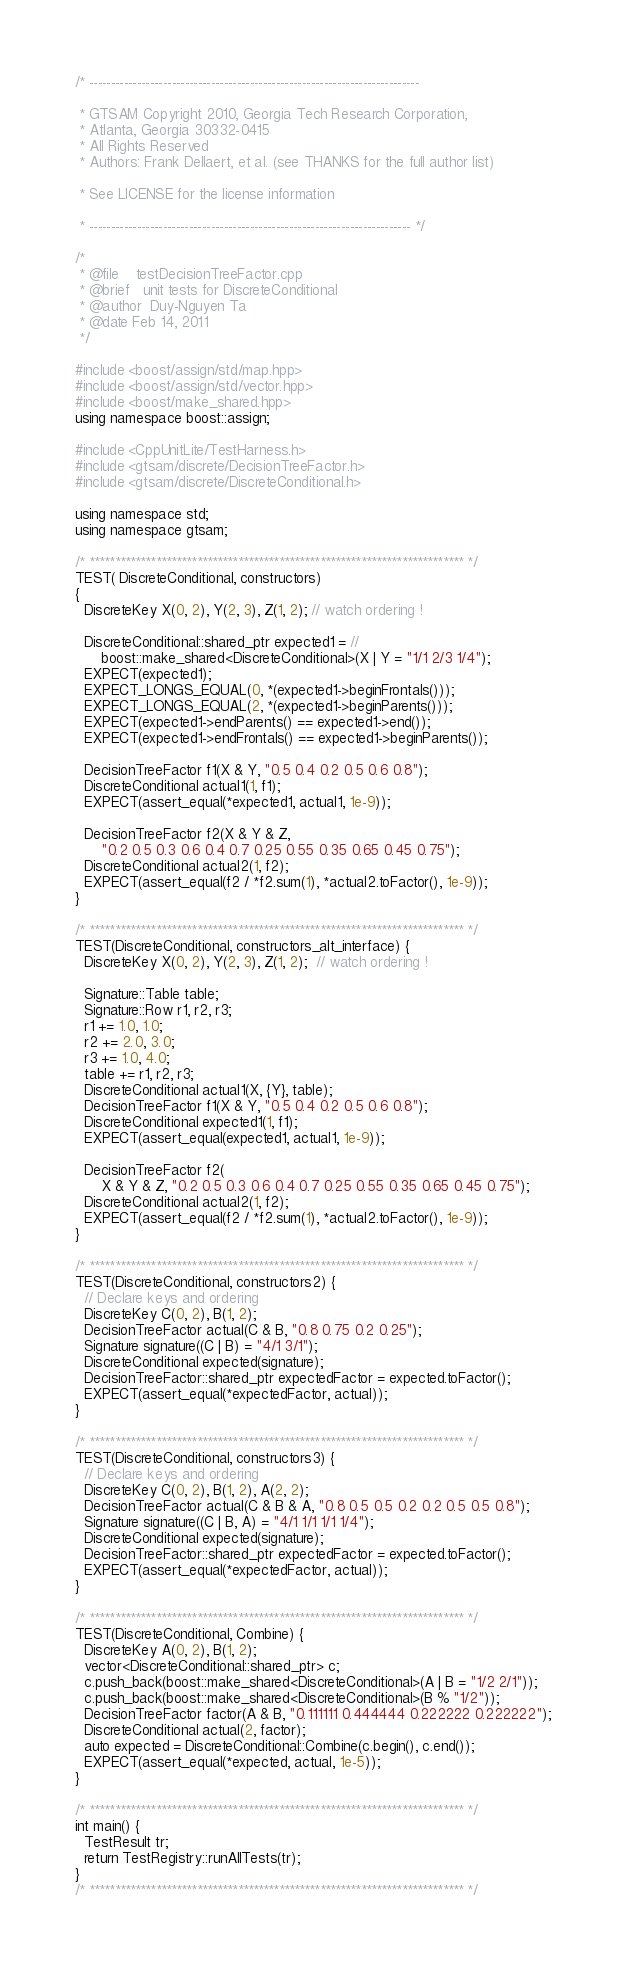<code> <loc_0><loc_0><loc_500><loc_500><_C++_>/* ----------------------------------------------------------------------------

 * GTSAM Copyright 2010, Georgia Tech Research Corporation,
 * Atlanta, Georgia 30332-0415
 * All Rights Reserved
 * Authors: Frank Dellaert, et al. (see THANKS for the full author list)

 * See LICENSE for the license information

 * -------------------------------------------------------------------------- */

/*
 * @file    testDecisionTreeFactor.cpp
 * @brief   unit tests for DiscreteConditional
 * @author  Duy-Nguyen Ta
 * @date Feb 14, 2011
 */

#include <boost/assign/std/map.hpp>
#include <boost/assign/std/vector.hpp>
#include <boost/make_shared.hpp>
using namespace boost::assign;

#include <CppUnitLite/TestHarness.h>
#include <gtsam/discrete/DecisionTreeFactor.h>
#include <gtsam/discrete/DiscreteConditional.h>

using namespace std;
using namespace gtsam;

/* ************************************************************************* */
TEST( DiscreteConditional, constructors)
{
  DiscreteKey X(0, 2), Y(2, 3), Z(1, 2); // watch ordering !

  DiscreteConditional::shared_ptr expected1 = //
      boost::make_shared<DiscreteConditional>(X | Y = "1/1 2/3 1/4");
  EXPECT(expected1);
  EXPECT_LONGS_EQUAL(0, *(expected1->beginFrontals()));
  EXPECT_LONGS_EQUAL(2, *(expected1->beginParents()));
  EXPECT(expected1->endParents() == expected1->end());
  EXPECT(expected1->endFrontals() == expected1->beginParents());
  
  DecisionTreeFactor f1(X & Y, "0.5 0.4 0.2 0.5 0.6 0.8");
  DiscreteConditional actual1(1, f1);
  EXPECT(assert_equal(*expected1, actual1, 1e-9));

  DecisionTreeFactor f2(X & Y & Z,
      "0.2 0.5 0.3 0.6 0.4 0.7 0.25 0.55 0.35 0.65 0.45 0.75");
  DiscreteConditional actual2(1, f2);
  EXPECT(assert_equal(f2 / *f2.sum(1), *actual2.toFactor(), 1e-9));
}

/* ************************************************************************* */
TEST(DiscreteConditional, constructors_alt_interface) {
  DiscreteKey X(0, 2), Y(2, 3), Z(1, 2);  // watch ordering !

  Signature::Table table;
  Signature::Row r1, r2, r3;
  r1 += 1.0, 1.0;
  r2 += 2.0, 3.0;
  r3 += 1.0, 4.0;
  table += r1, r2, r3;
  DiscreteConditional actual1(X, {Y}, table);
  DecisionTreeFactor f1(X & Y, "0.5 0.4 0.2 0.5 0.6 0.8");
  DiscreteConditional expected1(1, f1);
  EXPECT(assert_equal(expected1, actual1, 1e-9));

  DecisionTreeFactor f2(
      X & Y & Z, "0.2 0.5 0.3 0.6 0.4 0.7 0.25 0.55 0.35 0.65 0.45 0.75");
  DiscreteConditional actual2(1, f2);
  EXPECT(assert_equal(f2 / *f2.sum(1), *actual2.toFactor(), 1e-9));
}

/* ************************************************************************* */
TEST(DiscreteConditional, constructors2) {
  // Declare keys and ordering
  DiscreteKey C(0, 2), B(1, 2);
  DecisionTreeFactor actual(C & B, "0.8 0.75 0.2 0.25");
  Signature signature((C | B) = "4/1 3/1");
  DiscreteConditional expected(signature);
  DecisionTreeFactor::shared_ptr expectedFactor = expected.toFactor();
  EXPECT(assert_equal(*expectedFactor, actual));
}

/* ************************************************************************* */
TEST(DiscreteConditional, constructors3) {
  // Declare keys and ordering
  DiscreteKey C(0, 2), B(1, 2), A(2, 2);
  DecisionTreeFactor actual(C & B & A, "0.8 0.5 0.5 0.2 0.2 0.5 0.5 0.8");
  Signature signature((C | B, A) = "4/1 1/1 1/1 1/4");
  DiscreteConditional expected(signature);
  DecisionTreeFactor::shared_ptr expectedFactor = expected.toFactor();
  EXPECT(assert_equal(*expectedFactor, actual));
}

/* ************************************************************************* */
TEST(DiscreteConditional, Combine) {
  DiscreteKey A(0, 2), B(1, 2);
  vector<DiscreteConditional::shared_ptr> c;
  c.push_back(boost::make_shared<DiscreteConditional>(A | B = "1/2 2/1"));
  c.push_back(boost::make_shared<DiscreteConditional>(B % "1/2"));
  DecisionTreeFactor factor(A & B, "0.111111 0.444444 0.222222 0.222222");
  DiscreteConditional actual(2, factor);
  auto expected = DiscreteConditional::Combine(c.begin(), c.end());
  EXPECT(assert_equal(*expected, actual, 1e-5));
}

/* ************************************************************************* */
int main() {
  TestResult tr;
  return TestRegistry::runAllTests(tr);
}
/* ************************************************************************* */
</code> 